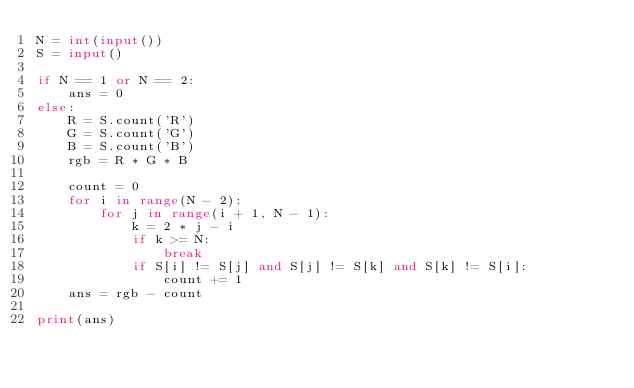<code> <loc_0><loc_0><loc_500><loc_500><_Python_>N = int(input())
S = input()

if N == 1 or N == 2:
    ans = 0
else:
    R = S.count('R')
    G = S.count('G')
    B = S.count('B')
    rgb = R * G * B

    count = 0
    for i in range(N - 2):
        for j in range(i + 1, N - 1):
            k = 2 * j - i
            if k >= N:
                break 
            if S[i] != S[j] and S[j] != S[k] and S[k] != S[i]:
                count += 1
    ans = rgb - count

print(ans)</code> 